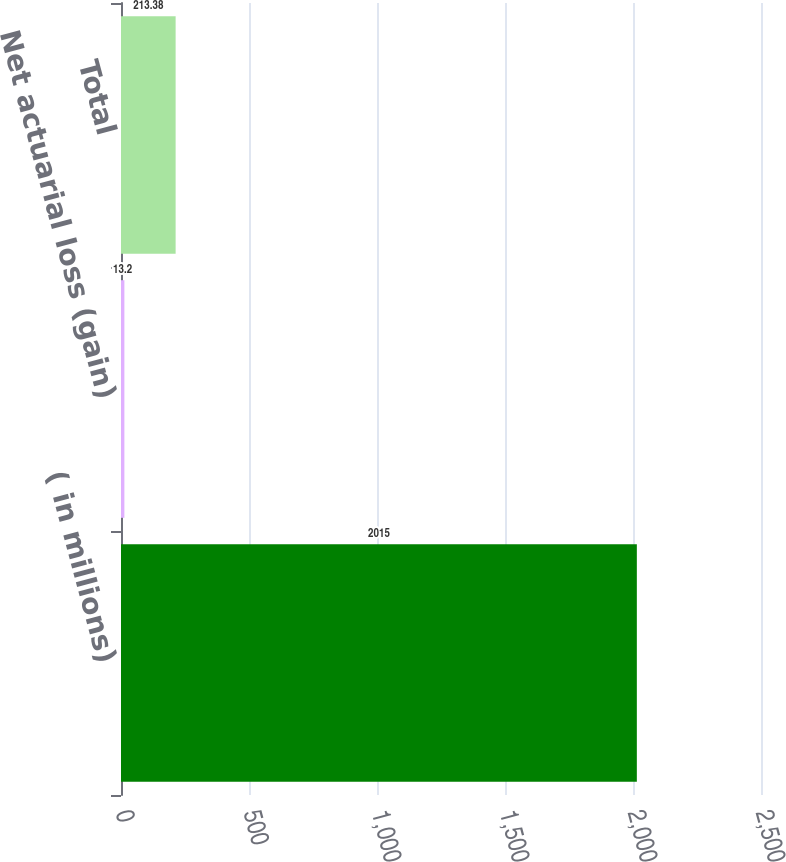Convert chart. <chart><loc_0><loc_0><loc_500><loc_500><bar_chart><fcel>( in millions)<fcel>Net actuarial loss (gain)<fcel>Total<nl><fcel>2015<fcel>13.2<fcel>213.38<nl></chart> 